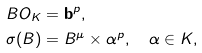<formula> <loc_0><loc_0><loc_500><loc_500>& B O _ { K } = \mathbf b ^ { p } , \\ & \sigma ( B ) = B ^ { \mu } \times \alpha ^ { p } , \quad \alpha \in K , \\</formula> 